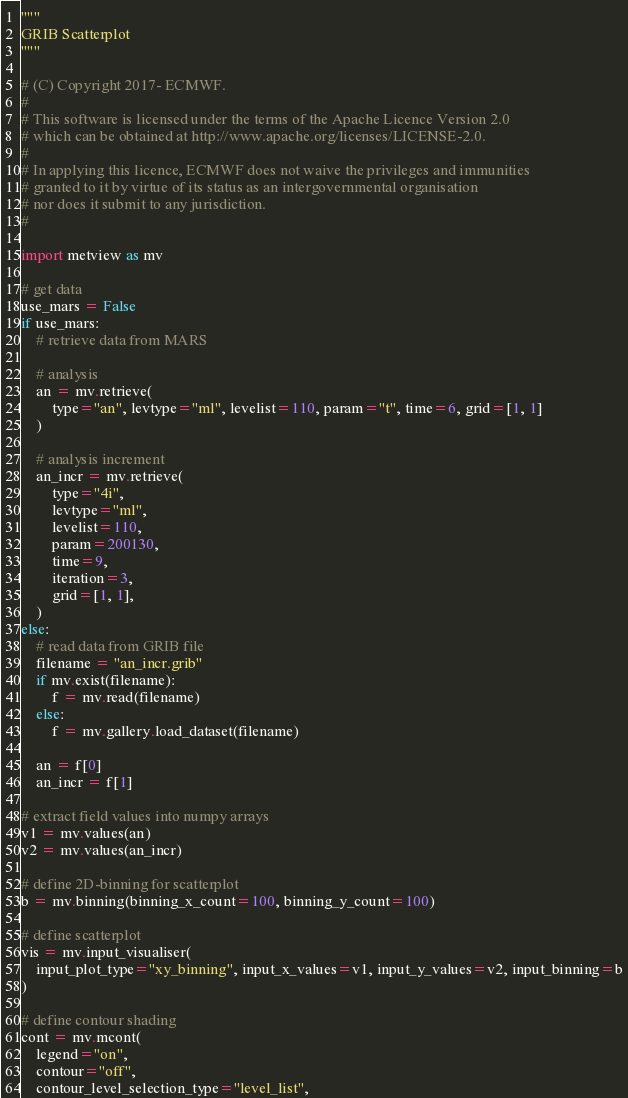Convert code to text. <code><loc_0><loc_0><loc_500><loc_500><_Python_>"""
GRIB Scatterplot
"""

# (C) Copyright 2017- ECMWF.
#
# This software is licensed under the terms of the Apache Licence Version 2.0
# which can be obtained at http://www.apache.org/licenses/LICENSE-2.0.
#
# In applying this licence, ECMWF does not waive the privileges and immunities
# granted to it by virtue of its status as an intergovernmental organisation
# nor does it submit to any jurisdiction.
#

import metview as mv

# get data
use_mars = False
if use_mars:
    # retrieve data from MARS

    # analysis
    an = mv.retrieve(
        type="an", levtype="ml", levelist=110, param="t", time=6, grid=[1, 1]
    )

    # analysis increment
    an_incr = mv.retrieve(
        type="4i",
        levtype="ml",
        levelist=110,
        param=200130,
        time=9,
        iteration=3,
        grid=[1, 1],
    )
else:
    # read data from GRIB file
    filename = "an_incr.grib"
    if mv.exist(filename):
        f = mv.read(filename)
    else:
        f = mv.gallery.load_dataset(filename)

    an = f[0]
    an_incr = f[1]

# extract field values into numpy arrays
v1 = mv.values(an)
v2 = mv.values(an_incr)

# define 2D-binning for scatterplot
b = mv.binning(binning_x_count=100, binning_y_count=100)

# define scatterplot
vis = mv.input_visualiser(
    input_plot_type="xy_binning", input_x_values=v1, input_y_values=v2, input_binning=b
)

# define contour shading
cont = mv.mcont(
    legend="on",
    contour="off",
    contour_level_selection_type="level_list",</code> 